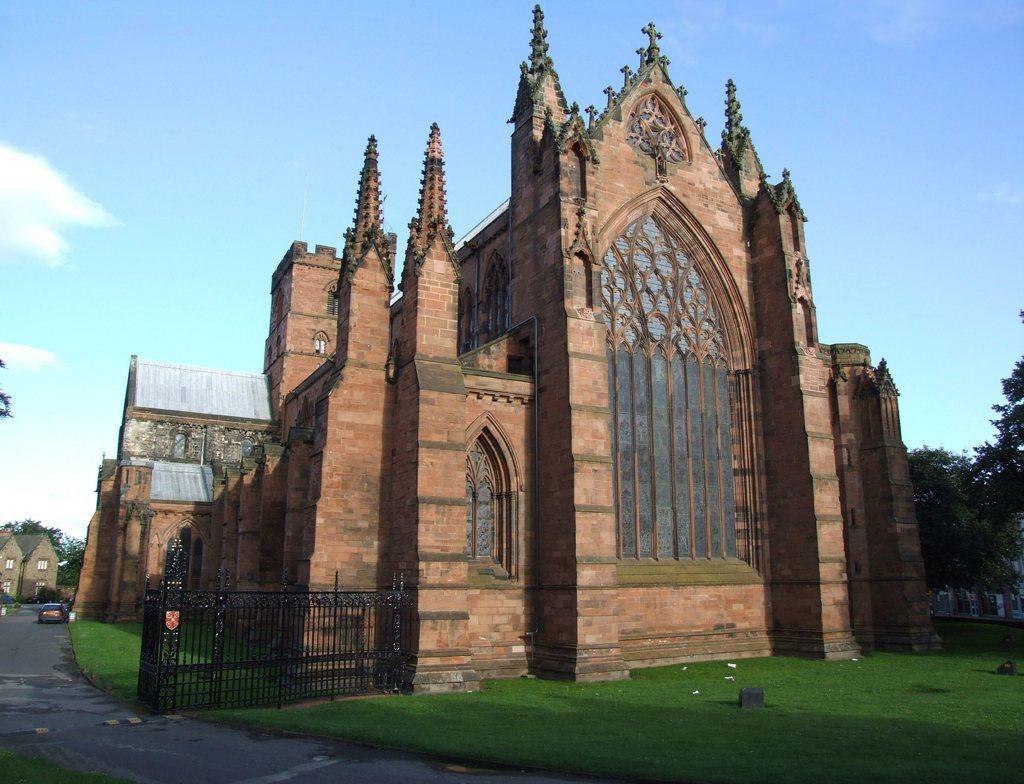How would you summarize this image in a sentence or two? There is a church with windows. Near to the church there is railing and grass lawn. In the back there are trees and sky. Also there is a road. On the road there is a car. In the back there is a building with windows. 